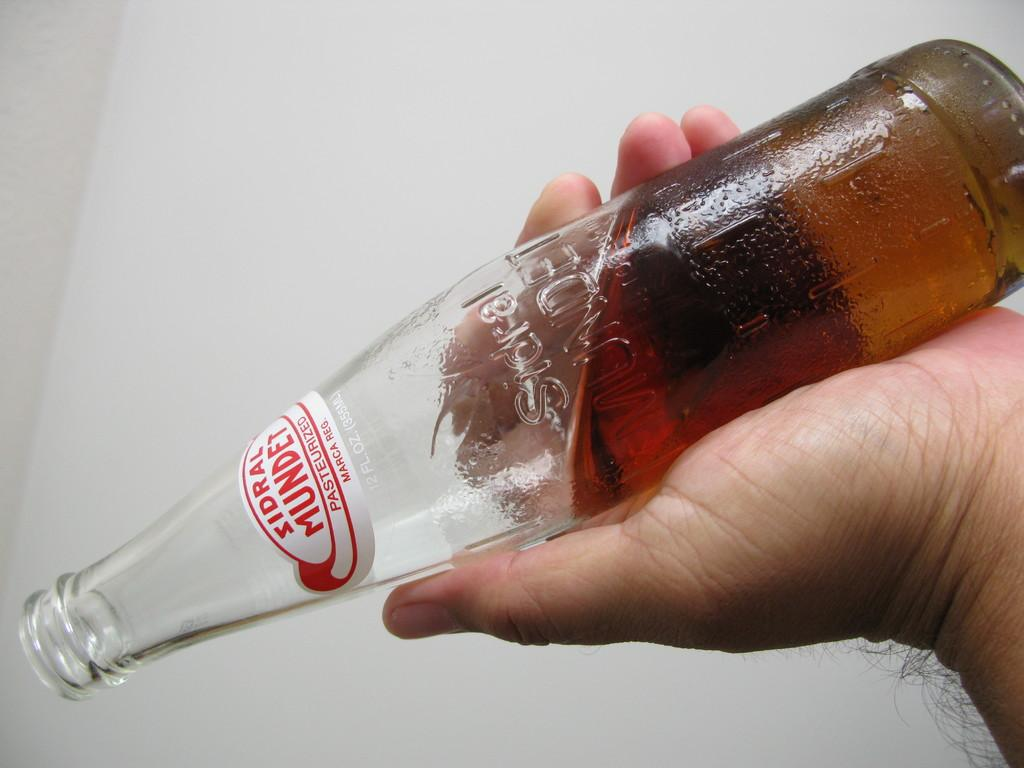<image>
Give a short and clear explanation of the subsequent image. a bottle of zidral mundet being held practically upside down by someone 